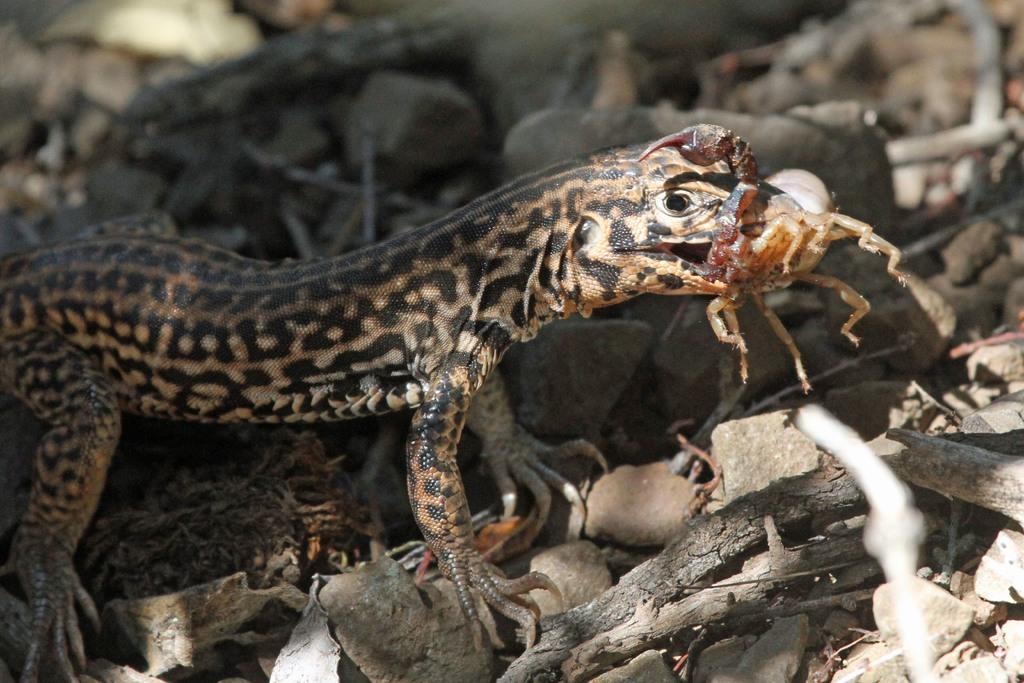What type of living organism can be seen in the image? There is a species visible in the image. What other objects are present in the image besides the living organism? There are stones in the image. Where is the nest of the species located in the image? There is no nest visible in the image. What type of quartz can be seen in the image? There is no quartz present in the image. 